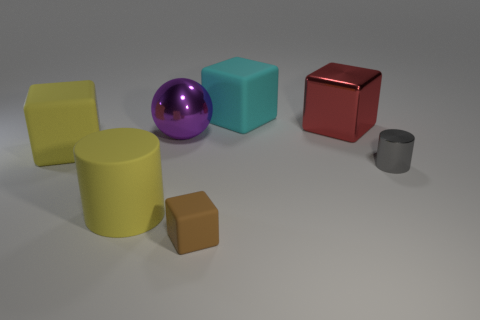What is the material of the large block left of the large purple metal object?
Keep it short and to the point. Rubber. Are there fewer metallic cylinders in front of the small brown block than small cyan spheres?
Offer a very short reply. No. Is the shape of the big red metal thing the same as the gray object?
Provide a succinct answer. No. Are there any other things that have the same shape as the brown object?
Your answer should be very brief. Yes. Is there a red block?
Make the answer very short. Yes. There is a cyan object; does it have the same shape as the metallic thing on the left side of the cyan object?
Provide a succinct answer. No. What material is the yellow thing to the right of the yellow rubber thing behind the yellow matte cylinder made of?
Your answer should be very brief. Rubber. What color is the metal ball?
Your answer should be very brief. Purple. Is the color of the cube that is in front of the yellow rubber cylinder the same as the cylinder that is on the right side of the small rubber thing?
Your answer should be very brief. No. What is the size of the other thing that is the same shape as the small shiny thing?
Provide a short and direct response. Large. 